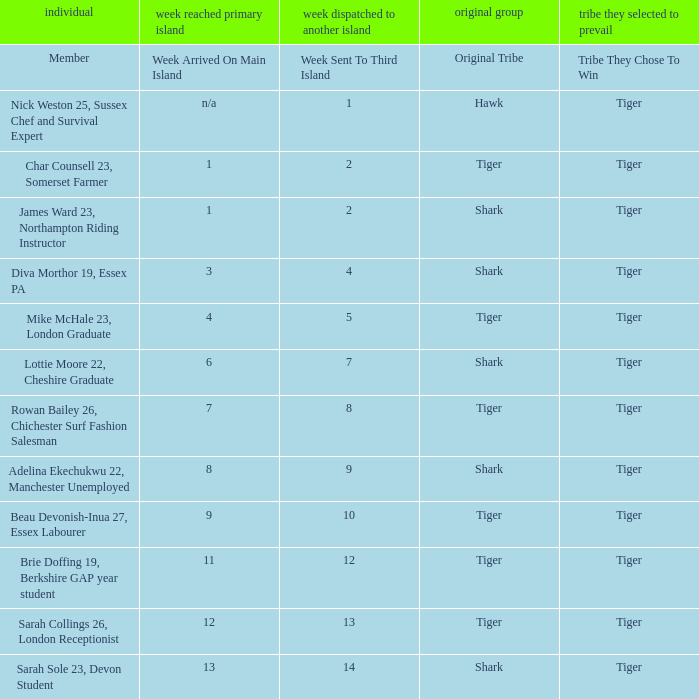Who was sent to the third island in week 1? Nick Weston 25, Sussex Chef and Survival Expert. 